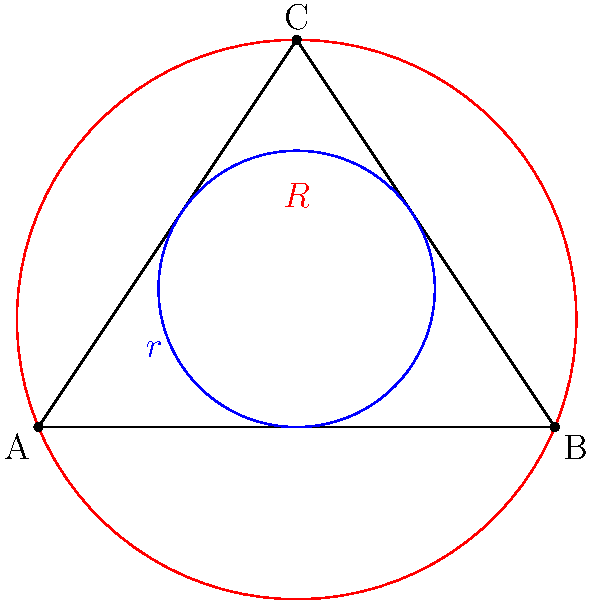In a triangle ABC, the radius of the inscribed circle is denoted as $r$ and the radius of the circumscribed circle is denoted as $R$. If the area of the triangle is $S$ and its semi-perimeter is $s$, prove that the following relation holds:

$$ \frac{1}{r} + \frac{1}{R} = \frac{2S}{rs} $$

How might this mathematical relationship be analogous to the balance between subtle background music and prominent sound effects in video game scoring? Let's approach this proof step-by-step:

1) First, recall that the area of a triangle can be expressed in terms of its semi-perimeter and the radius of its inscribed circle:

   $S = rs$

2) Also, recall Euler's theorem relating the circumradius $R$, inradius $r$, and the semi-perimeter $s$:

   $R = \frac{abc}{4S}$, where $a$, $b$, and $c$ are the side lengths of the triangle.

3) We know that $s = \frac{a+b+c}{2}$, so $abc = (2s-a)(2s-b)(2s-c)$

4) Substituting this into Euler's theorem:

   $R = \frac{(2s-a)(2s-b)(2s-c)}{4S}$

5) Using the formula for the area of a triangle in terms of semi-perimeter (Heron's formula):

   $S = \sqrt{s(s-a)(s-b)(s-c)}$

6) Squaring both sides:

   $S^2 = s(s-a)(s-b)(s-c)$

7) Multiplying both sides by 4:

   $4S^2 = 4s(s-a)(s-b)(s-c)$

8) Dividing the equation from step 4 by this:

   $\frac{1}{R} = \frac{4S^2}{(2s-a)(2s-b)(2s-c)} \cdot \frac{4s(s-a)(s-b)(s-c)}{4S^2} = \frac{s}{S}$

9) From step 1, we know that $\frac{1}{r} = \frac{S}{rs}$

10) Adding the results from steps 8 and 9:

    $\frac{1}{r} + \frac{1}{R} = \frac{S}{rs} + \frac{s}{S} = \frac{S^2 + r^2s^2}{rsS} = \frac{S^2 + S^2}{rsS} = \frac{2S}{rs}$

Thus, we have proved the relation $\frac{1}{r} + \frac{1}{R} = \frac{2S}{rs}$.

This relationship in geometry is analogous to balancing subtle background music ($r$) and prominent sound effects ($R$) in video game scoring. Just as the inscribed and circumscribed circles complement each other to define the triangle's properties, background music and sound effects must work together to create a cohesive auditory experience, with their combined impact ($\frac{2S}{rs}$) defining the overall sonic landscape of the game.
Answer: $\frac{1}{r} + \frac{1}{R} = \frac{2S}{rs}$ 